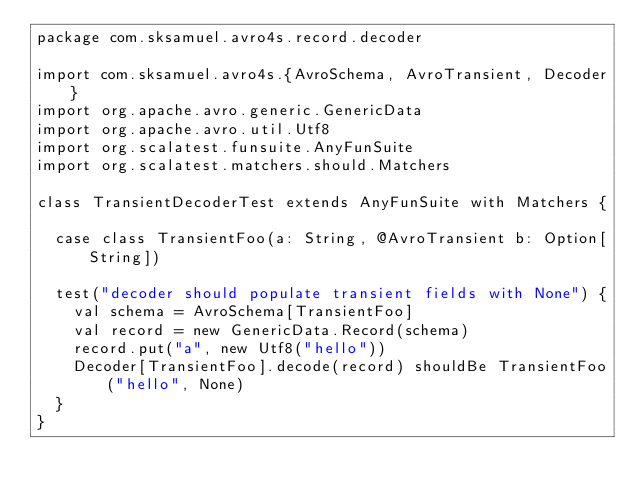Convert code to text. <code><loc_0><loc_0><loc_500><loc_500><_Scala_>package com.sksamuel.avro4s.record.decoder

import com.sksamuel.avro4s.{AvroSchema, AvroTransient, Decoder}
import org.apache.avro.generic.GenericData
import org.apache.avro.util.Utf8
import org.scalatest.funsuite.AnyFunSuite
import org.scalatest.matchers.should.Matchers

class TransientDecoderTest extends AnyFunSuite with Matchers {

  case class TransientFoo(a: String, @AvroTransient b: Option[String])

  test("decoder should populate transient fields with None") {
    val schema = AvroSchema[TransientFoo]
    val record = new GenericData.Record(schema)
    record.put("a", new Utf8("hello"))
    Decoder[TransientFoo].decode(record) shouldBe TransientFoo("hello", None)
  }
}
</code> 